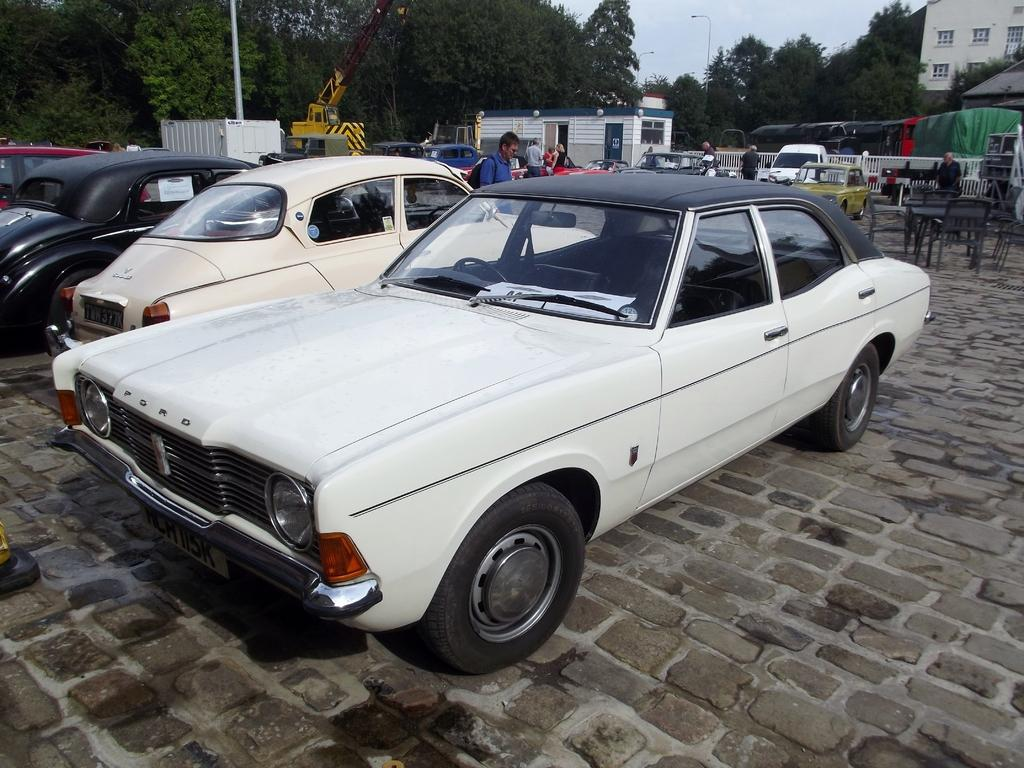What types of objects can be seen in the image? There are vehicles, tables, chairs, trees, street lights, and a building in the image. Are there any people present in the image? Yes, there are persons in the image. What structure can be seen in the image? There is a building in the image. What is attached to the pole in the image? There is a box attached to the pole in the image. What part of the natural environment is visible in the image? Trees and the sky are visible in the image. What type of arm can be seen holding a religious book in the image? There is no arm or religious book present in the image. Is there a bath visible in the image? No, there is no bath present in the image. 